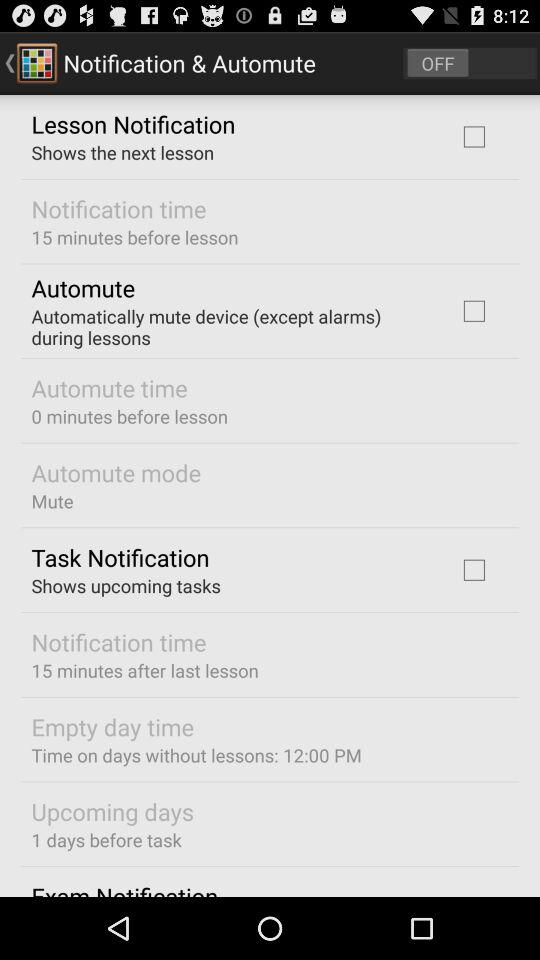What is the current status of the "Task Notification"? The current status of the "Task Notification" is "off". 